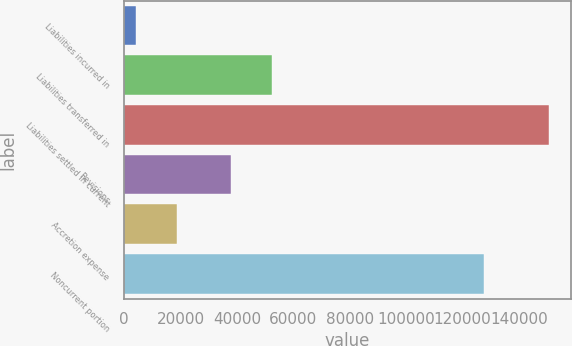Convert chart to OTSL. <chart><loc_0><loc_0><loc_500><loc_500><bar_chart><fcel>Liabilities incurred in<fcel>Liabilities transferred in<fcel>Liabilities settled in current<fcel>Revisions<fcel>Accretion expense<fcel>Noncurrent portion<nl><fcel>4086<fcel>52479.1<fcel>150847<fcel>37803<fcel>18762.1<fcel>127689<nl></chart> 